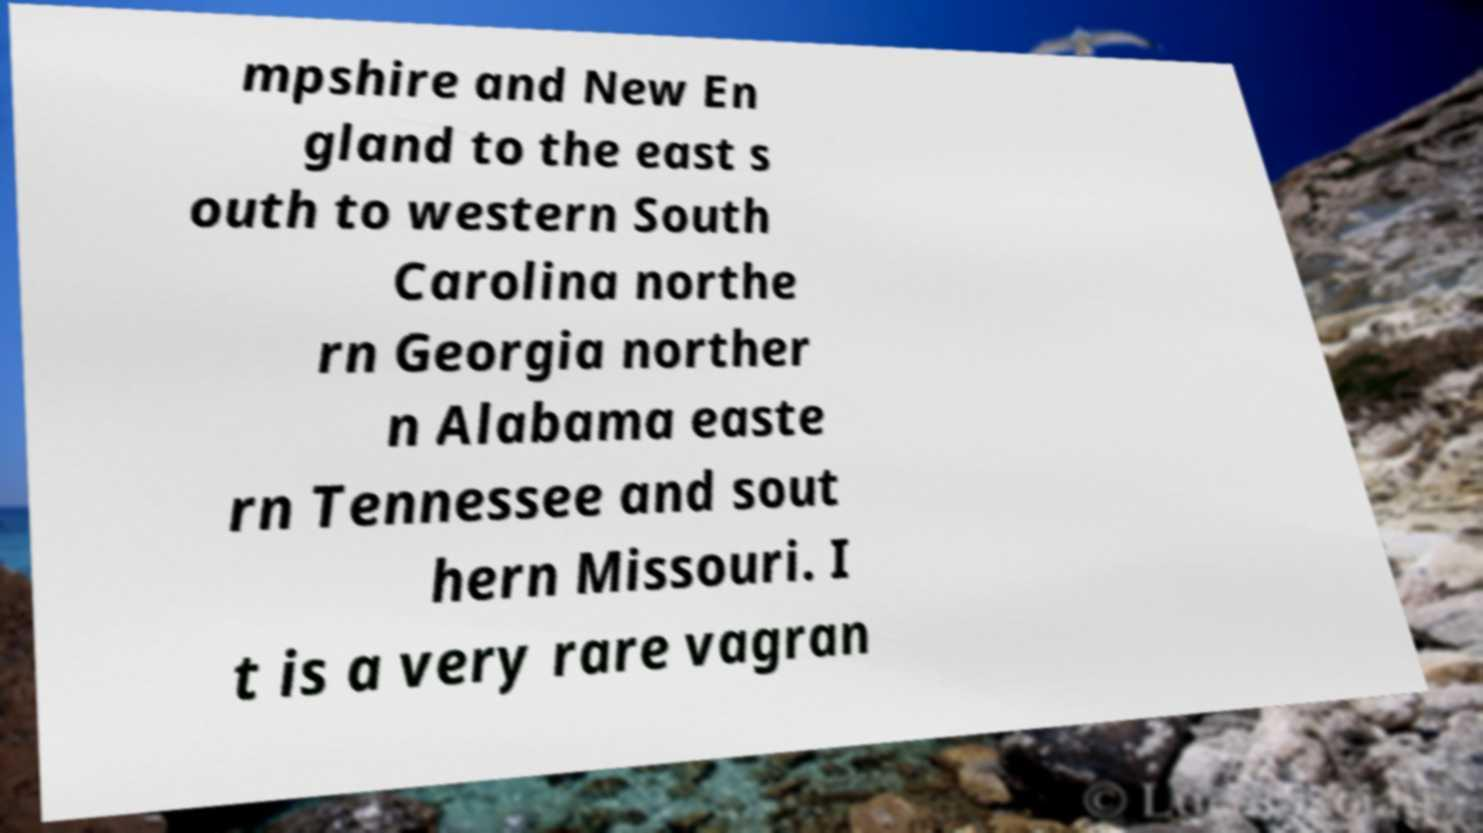Can you read and provide the text displayed in the image?This photo seems to have some interesting text. Can you extract and type it out for me? mpshire and New En gland to the east s outh to western South Carolina northe rn Georgia norther n Alabama easte rn Tennessee and sout hern Missouri. I t is a very rare vagran 